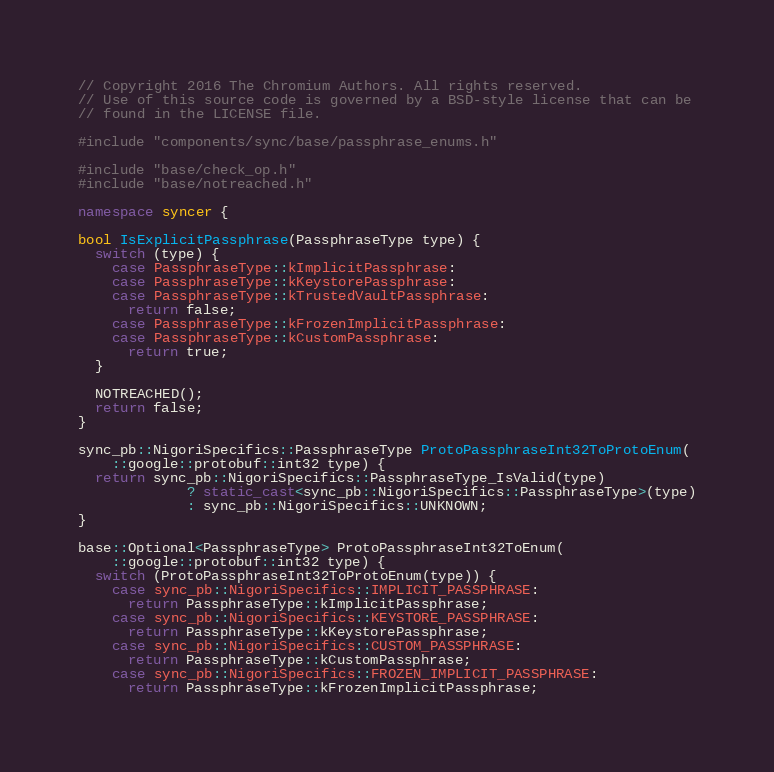Convert code to text. <code><loc_0><loc_0><loc_500><loc_500><_C++_>// Copyright 2016 The Chromium Authors. All rights reserved.
// Use of this source code is governed by a BSD-style license that can be
// found in the LICENSE file.

#include "components/sync/base/passphrase_enums.h"

#include "base/check_op.h"
#include "base/notreached.h"

namespace syncer {

bool IsExplicitPassphrase(PassphraseType type) {
  switch (type) {
    case PassphraseType::kImplicitPassphrase:
    case PassphraseType::kKeystorePassphrase:
    case PassphraseType::kTrustedVaultPassphrase:
      return false;
    case PassphraseType::kFrozenImplicitPassphrase:
    case PassphraseType::kCustomPassphrase:
      return true;
  }

  NOTREACHED();
  return false;
}

sync_pb::NigoriSpecifics::PassphraseType ProtoPassphraseInt32ToProtoEnum(
    ::google::protobuf::int32 type) {
  return sync_pb::NigoriSpecifics::PassphraseType_IsValid(type)
             ? static_cast<sync_pb::NigoriSpecifics::PassphraseType>(type)
             : sync_pb::NigoriSpecifics::UNKNOWN;
}

base::Optional<PassphraseType> ProtoPassphraseInt32ToEnum(
    ::google::protobuf::int32 type) {
  switch (ProtoPassphraseInt32ToProtoEnum(type)) {
    case sync_pb::NigoriSpecifics::IMPLICIT_PASSPHRASE:
      return PassphraseType::kImplicitPassphrase;
    case sync_pb::NigoriSpecifics::KEYSTORE_PASSPHRASE:
      return PassphraseType::kKeystorePassphrase;
    case sync_pb::NigoriSpecifics::CUSTOM_PASSPHRASE:
      return PassphraseType::kCustomPassphrase;
    case sync_pb::NigoriSpecifics::FROZEN_IMPLICIT_PASSPHRASE:
      return PassphraseType::kFrozenImplicitPassphrase;</code> 